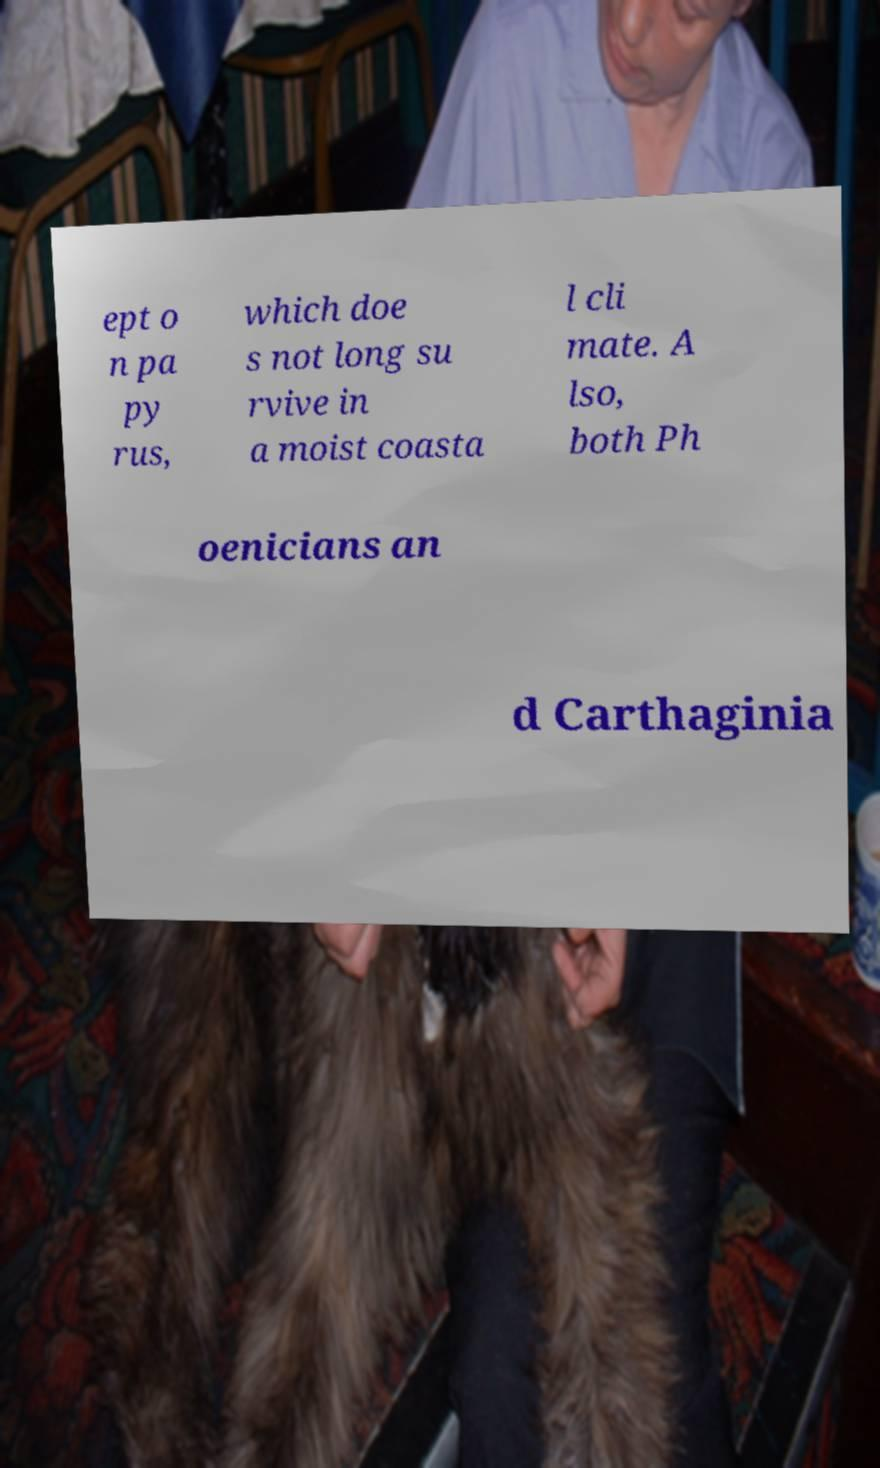Can you accurately transcribe the text from the provided image for me? ept o n pa py rus, which doe s not long su rvive in a moist coasta l cli mate. A lso, both Ph oenicians an d Carthaginia 